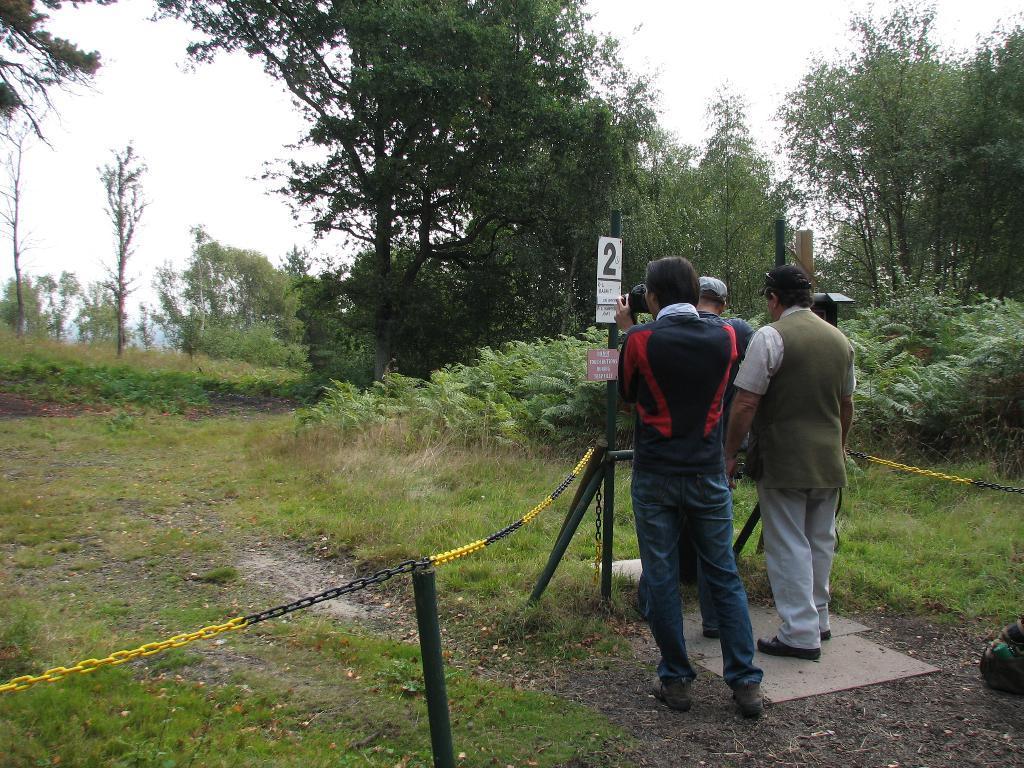Can you describe this image briefly? In the image we can see there are people standing, wearing clothes, shoes and two of them are wearing a cap. This is a camera, chain, pole, grass, plant, trees and a white sky. 